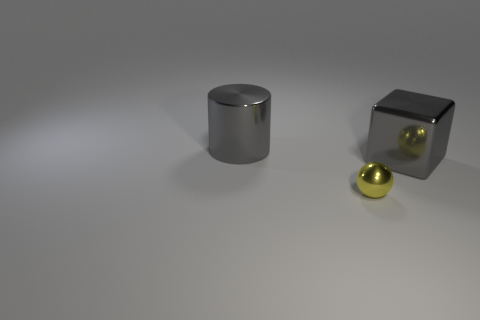Is the shiny cube the same size as the gray cylinder?
Ensure brevity in your answer.  Yes. Is there a gray cube of the same size as the gray cylinder?
Keep it short and to the point. Yes. What material is the gray thing that is to the left of the ball?
Your answer should be compact. Metal. There is a block that is made of the same material as the small yellow sphere; what color is it?
Ensure brevity in your answer.  Gray. How many shiny things are green objects or big gray objects?
Offer a very short reply. 2. What shape is the object that is the same size as the metallic cylinder?
Give a very brief answer. Cube. What number of things are gray shiny things in front of the metallic cylinder or gray metallic things behind the gray shiny block?
Offer a terse response. 2. What material is the gray object that is the same size as the gray block?
Your response must be concise. Metal. What number of other objects are there of the same material as the yellow thing?
Offer a terse response. 2. Are there the same number of big gray blocks in front of the small sphere and big things behind the big metal cylinder?
Your answer should be very brief. Yes. 